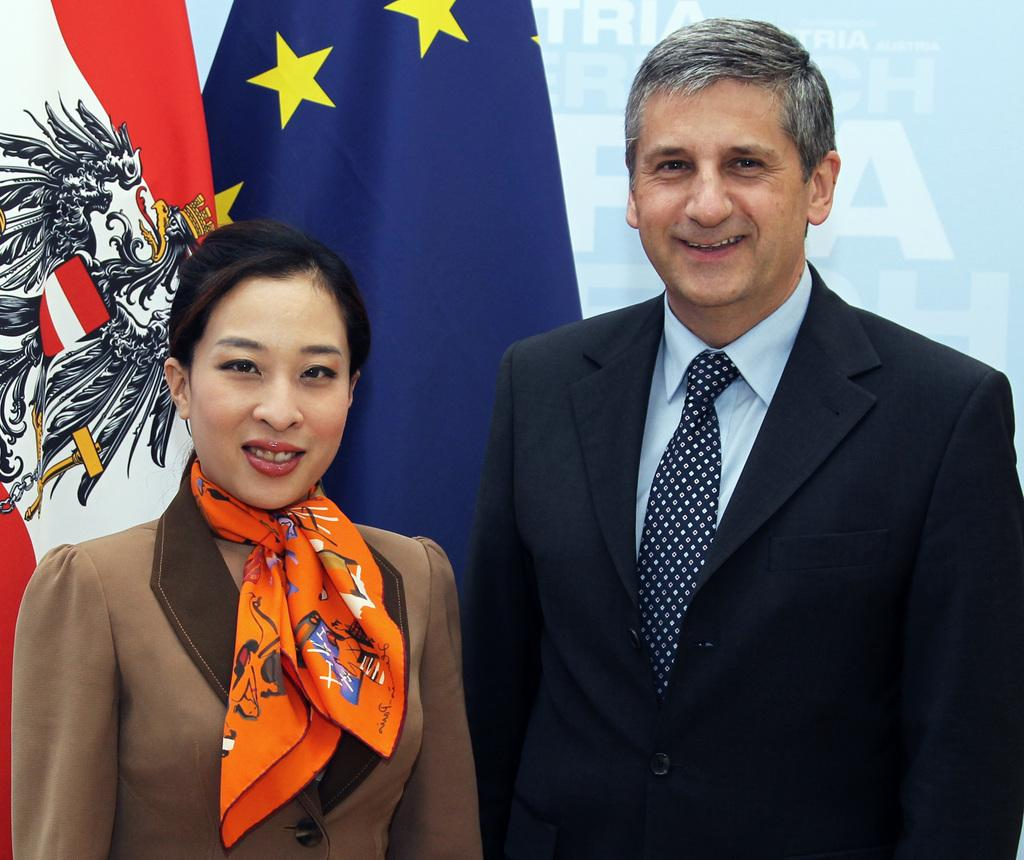Who is present in the image? There is a man and a woman in the image. What are the expressions on their faces? Both the man and the woman are smiling in the image. What else can be seen in the image? There are flags visible in the image. How many stars can be seen on the slope in the image? There are no stars or slopes present in the image; it features a man, a woman, and flags. 